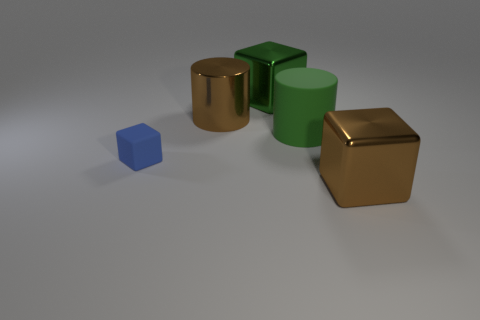Add 4 large brown cubes. How many objects exist? 9 Subtract all cylinders. How many objects are left? 3 Add 5 big shiny cylinders. How many big shiny cylinders are left? 6 Add 4 metal blocks. How many metal blocks exist? 6 Subtract 0 green balls. How many objects are left? 5 Subtract all large brown shiny blocks. Subtract all big green metallic objects. How many objects are left? 3 